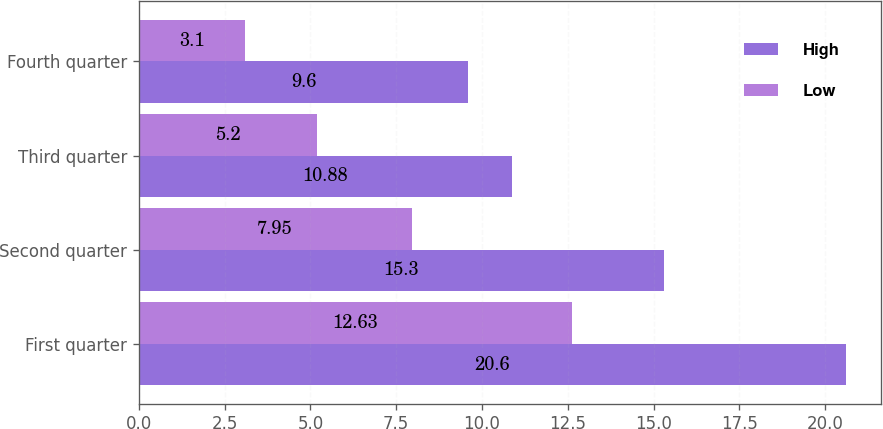Convert chart. <chart><loc_0><loc_0><loc_500><loc_500><stacked_bar_chart><ecel><fcel>First quarter<fcel>Second quarter<fcel>Third quarter<fcel>Fourth quarter<nl><fcel>High<fcel>20.6<fcel>15.3<fcel>10.88<fcel>9.6<nl><fcel>Low<fcel>12.63<fcel>7.95<fcel>5.2<fcel>3.1<nl></chart> 